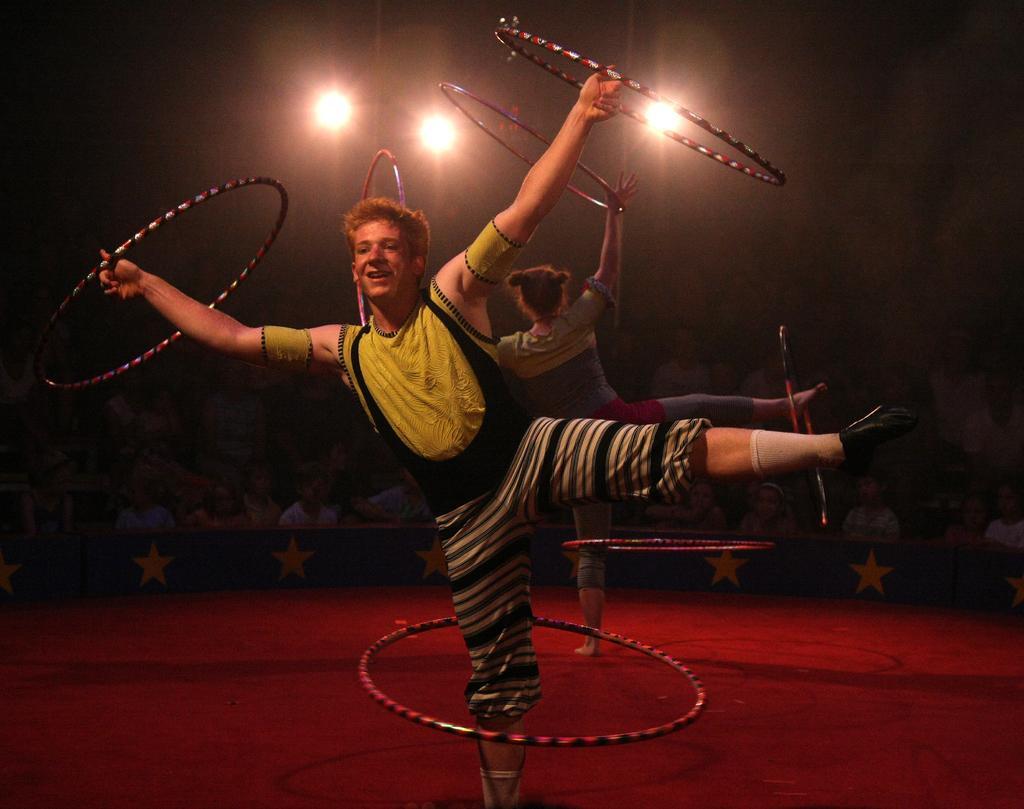Describe this image in one or two sentences. This picture shows a boy and a girl performing gymnastics on the stage with the rings and we see people seated and watching and we see few lights. 